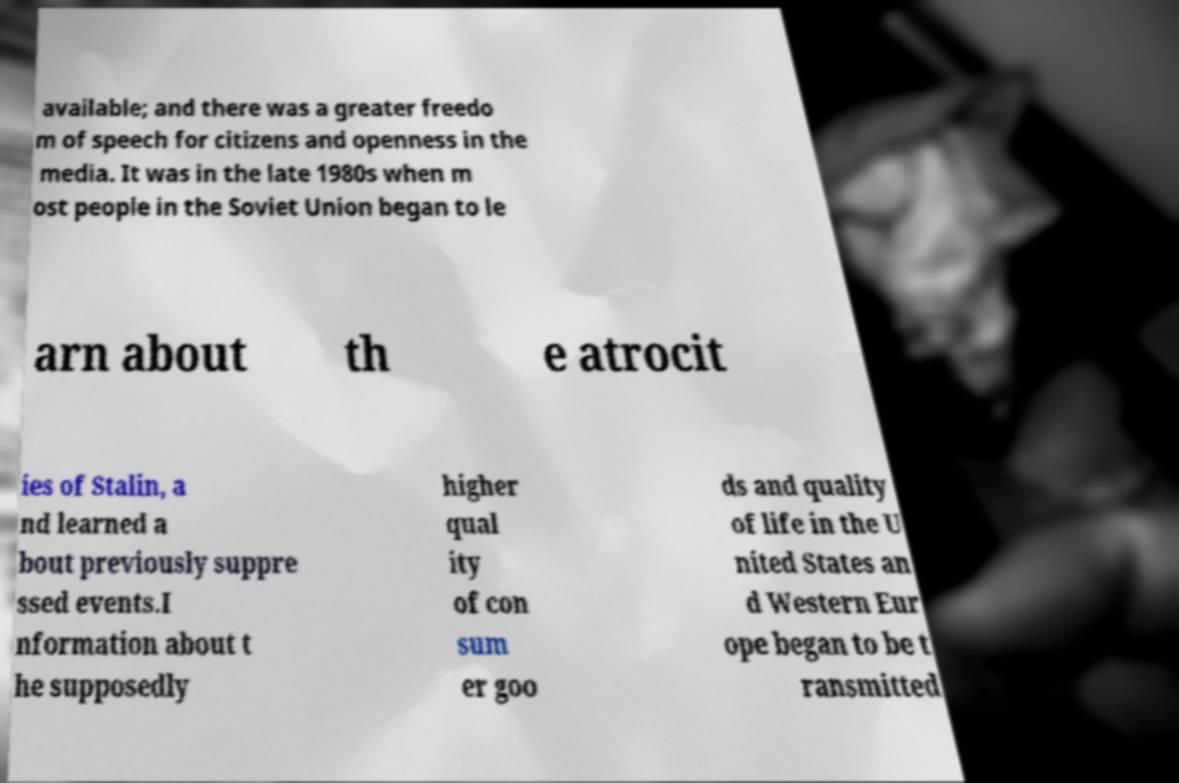Can you accurately transcribe the text from the provided image for me? available; and there was a greater freedo m of speech for citizens and openness in the media. It was in the late 1980s when m ost people in the Soviet Union began to le arn about th e atrocit ies of Stalin, a nd learned a bout previously suppre ssed events.I nformation about t he supposedly higher qual ity of con sum er goo ds and quality of life in the U nited States an d Western Eur ope began to be t ransmitted 